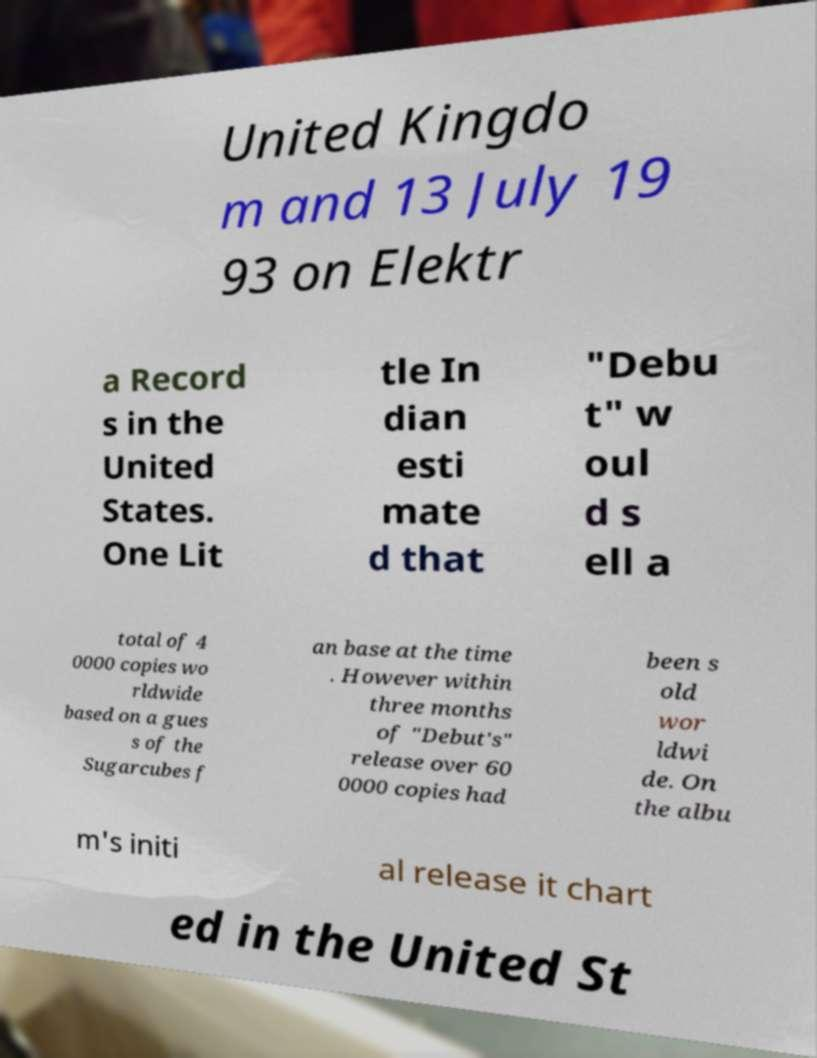Please identify and transcribe the text found in this image. United Kingdo m and 13 July 19 93 on Elektr a Record s in the United States. One Lit tle In dian esti mate d that "Debu t" w oul d s ell a total of 4 0000 copies wo rldwide based on a gues s of the Sugarcubes f an base at the time . However within three months of "Debut's" release over 60 0000 copies had been s old wor ldwi de. On the albu m's initi al release it chart ed in the United St 